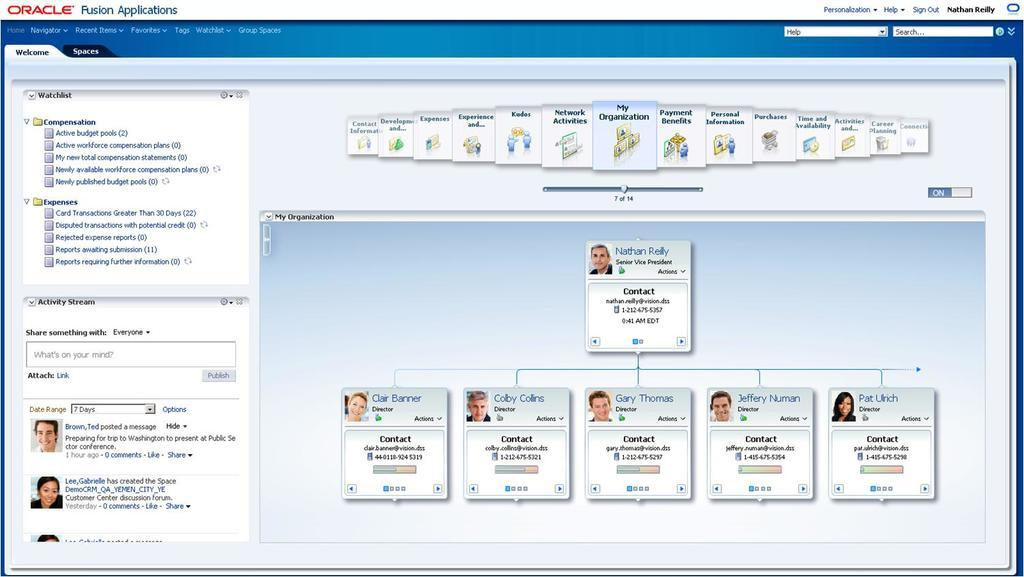What type of content is displayed in the image? The image is a web page. What can be seen in the images on the web page? There are images of humans on the web page. What other type of content is present on the web page besides images? There is text on the web page. What type of pump is used by the police in the image? There is no pump or police present in the image; it is a web page with images of humans and text. 